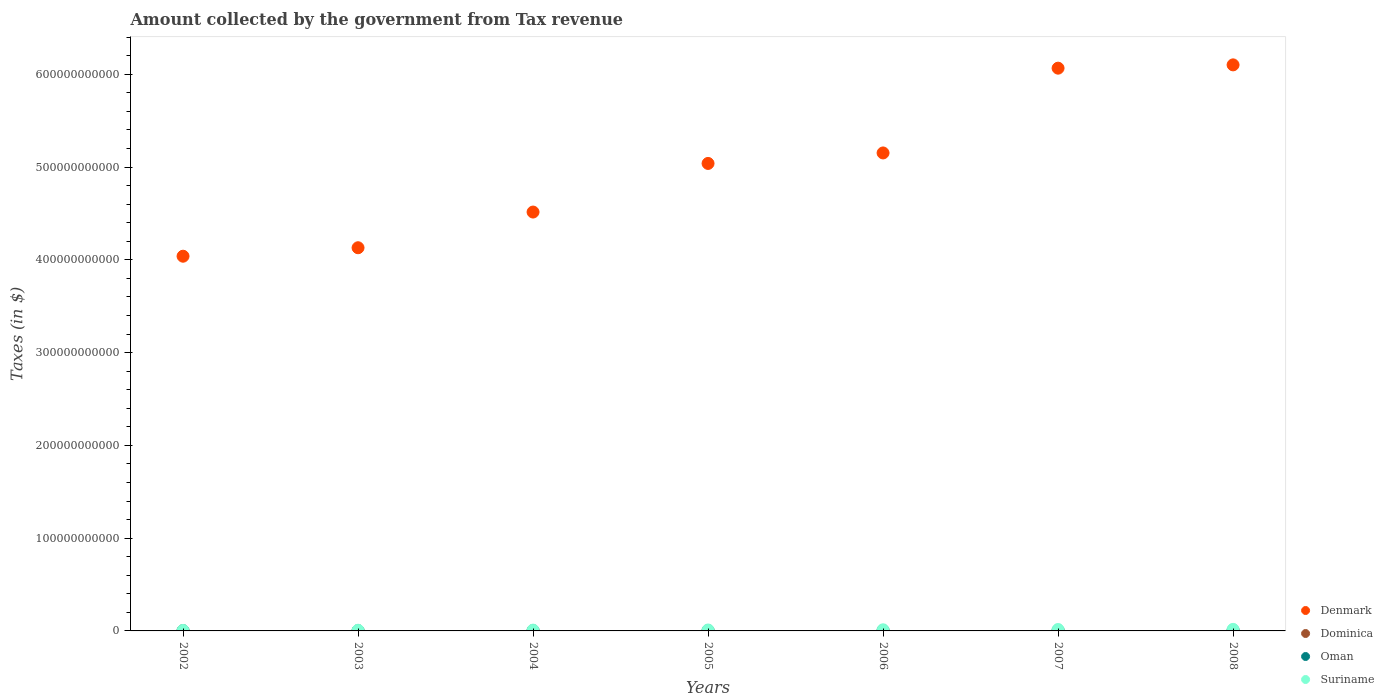How many different coloured dotlines are there?
Offer a terse response. 4. Is the number of dotlines equal to the number of legend labels?
Your answer should be very brief. Yes. What is the amount collected by the government from tax revenue in Oman in 2004?
Keep it short and to the point. 1.85e+08. Across all years, what is the maximum amount collected by the government from tax revenue in Oman?
Your answer should be compact. 5.66e+08. Across all years, what is the minimum amount collected by the government from tax revenue in Suriname?
Make the answer very short. 5.24e+08. What is the total amount collected by the government from tax revenue in Denmark in the graph?
Give a very brief answer. 3.50e+12. What is the difference between the amount collected by the government from tax revenue in Oman in 2004 and that in 2007?
Your response must be concise. -2.52e+08. What is the difference between the amount collected by the government from tax revenue in Suriname in 2004 and the amount collected by the government from tax revenue in Dominica in 2005?
Your response must be concise. 6.24e+08. What is the average amount collected by the government from tax revenue in Denmark per year?
Provide a short and direct response. 5.01e+11. In the year 2007, what is the difference between the amount collected by the government from tax revenue in Oman and amount collected by the government from tax revenue in Suriname?
Provide a short and direct response. -1.08e+09. What is the ratio of the amount collected by the government from tax revenue in Dominica in 2002 to that in 2005?
Keep it short and to the point. 0.71. Is the amount collected by the government from tax revenue in Oman in 2002 less than that in 2008?
Your answer should be compact. Yes. Is the difference between the amount collected by the government from tax revenue in Oman in 2006 and 2007 greater than the difference between the amount collected by the government from tax revenue in Suriname in 2006 and 2007?
Your answer should be very brief. Yes. What is the difference between the highest and the second highest amount collected by the government from tax revenue in Oman?
Provide a succinct answer. 1.28e+08. What is the difference between the highest and the lowest amount collected by the government from tax revenue in Denmark?
Offer a terse response. 2.06e+11. Is it the case that in every year, the sum of the amount collected by the government from tax revenue in Suriname and amount collected by the government from tax revenue in Denmark  is greater than the sum of amount collected by the government from tax revenue in Oman and amount collected by the government from tax revenue in Dominica?
Provide a short and direct response. Yes. Is the amount collected by the government from tax revenue in Suriname strictly greater than the amount collected by the government from tax revenue in Oman over the years?
Provide a short and direct response. Yes. Is the amount collected by the government from tax revenue in Oman strictly less than the amount collected by the government from tax revenue in Dominica over the years?
Provide a succinct answer. No. What is the difference between two consecutive major ticks on the Y-axis?
Provide a succinct answer. 1.00e+11. Are the values on the major ticks of Y-axis written in scientific E-notation?
Your response must be concise. No. Where does the legend appear in the graph?
Offer a very short reply. Bottom right. What is the title of the graph?
Offer a terse response. Amount collected by the government from Tax revenue. What is the label or title of the Y-axis?
Offer a very short reply. Taxes (in $). What is the Taxes (in $) of Denmark in 2002?
Give a very brief answer. 4.04e+11. What is the Taxes (in $) of Dominica in 2002?
Offer a terse response. 1.62e+08. What is the Taxes (in $) of Oman in 2002?
Your answer should be very brief. 1.55e+08. What is the Taxes (in $) of Suriname in 2002?
Keep it short and to the point. 5.24e+08. What is the Taxes (in $) in Denmark in 2003?
Your answer should be very brief. 4.13e+11. What is the Taxes (in $) of Dominica in 2003?
Keep it short and to the point. 1.79e+08. What is the Taxes (in $) of Oman in 2003?
Make the answer very short. 1.70e+08. What is the Taxes (in $) in Suriname in 2003?
Ensure brevity in your answer.  7.12e+08. What is the Taxes (in $) of Denmark in 2004?
Keep it short and to the point. 4.52e+11. What is the Taxes (in $) in Dominica in 2004?
Your answer should be very brief. 2.05e+08. What is the Taxes (in $) of Oman in 2004?
Keep it short and to the point. 1.85e+08. What is the Taxes (in $) of Suriname in 2004?
Ensure brevity in your answer.  8.53e+08. What is the Taxes (in $) of Denmark in 2005?
Give a very brief answer. 5.04e+11. What is the Taxes (in $) in Dominica in 2005?
Give a very brief answer. 2.29e+08. What is the Taxes (in $) of Oman in 2005?
Offer a very short reply. 2.39e+08. What is the Taxes (in $) of Suriname in 2005?
Make the answer very short. 1.01e+09. What is the Taxes (in $) in Denmark in 2006?
Your answer should be very brief. 5.15e+11. What is the Taxes (in $) in Dominica in 2006?
Your answer should be compact. 2.48e+08. What is the Taxes (in $) in Oman in 2006?
Offer a very short reply. 2.78e+08. What is the Taxes (in $) of Suriname in 2006?
Your response must be concise. 1.21e+09. What is the Taxes (in $) of Denmark in 2007?
Give a very brief answer. 6.07e+11. What is the Taxes (in $) of Dominica in 2007?
Ensure brevity in your answer.  2.86e+08. What is the Taxes (in $) in Oman in 2007?
Your answer should be compact. 4.38e+08. What is the Taxes (in $) in Suriname in 2007?
Provide a short and direct response. 1.52e+09. What is the Taxes (in $) in Denmark in 2008?
Ensure brevity in your answer.  6.10e+11. What is the Taxes (in $) in Dominica in 2008?
Offer a terse response. 3.07e+08. What is the Taxes (in $) of Oman in 2008?
Keep it short and to the point. 5.66e+08. What is the Taxes (in $) in Suriname in 2008?
Provide a short and direct response. 1.68e+09. Across all years, what is the maximum Taxes (in $) in Denmark?
Give a very brief answer. 6.10e+11. Across all years, what is the maximum Taxes (in $) of Dominica?
Your response must be concise. 3.07e+08. Across all years, what is the maximum Taxes (in $) in Oman?
Offer a terse response. 5.66e+08. Across all years, what is the maximum Taxes (in $) of Suriname?
Your answer should be compact. 1.68e+09. Across all years, what is the minimum Taxes (in $) of Denmark?
Provide a succinct answer. 4.04e+11. Across all years, what is the minimum Taxes (in $) of Dominica?
Offer a terse response. 1.62e+08. Across all years, what is the minimum Taxes (in $) in Oman?
Offer a very short reply. 1.55e+08. Across all years, what is the minimum Taxes (in $) in Suriname?
Provide a succinct answer. 5.24e+08. What is the total Taxes (in $) in Denmark in the graph?
Offer a very short reply. 3.50e+12. What is the total Taxes (in $) of Dominica in the graph?
Ensure brevity in your answer.  1.62e+09. What is the total Taxes (in $) of Oman in the graph?
Ensure brevity in your answer.  2.03e+09. What is the total Taxes (in $) of Suriname in the graph?
Give a very brief answer. 7.51e+09. What is the difference between the Taxes (in $) of Denmark in 2002 and that in 2003?
Ensure brevity in your answer.  -9.13e+09. What is the difference between the Taxes (in $) in Dominica in 2002 and that in 2003?
Provide a short and direct response. -1.74e+07. What is the difference between the Taxes (in $) in Oman in 2002 and that in 2003?
Make the answer very short. -1.49e+07. What is the difference between the Taxes (in $) in Suriname in 2002 and that in 2003?
Your response must be concise. -1.88e+08. What is the difference between the Taxes (in $) of Denmark in 2002 and that in 2004?
Provide a succinct answer. -4.76e+1. What is the difference between the Taxes (in $) of Dominica in 2002 and that in 2004?
Provide a short and direct response. -4.32e+07. What is the difference between the Taxes (in $) in Oman in 2002 and that in 2004?
Offer a very short reply. -3.07e+07. What is the difference between the Taxes (in $) in Suriname in 2002 and that in 2004?
Ensure brevity in your answer.  -3.29e+08. What is the difference between the Taxes (in $) in Denmark in 2002 and that in 2005?
Provide a succinct answer. -1.00e+11. What is the difference between the Taxes (in $) of Dominica in 2002 and that in 2005?
Offer a very short reply. -6.73e+07. What is the difference between the Taxes (in $) of Oman in 2002 and that in 2005?
Provide a short and direct response. -8.40e+07. What is the difference between the Taxes (in $) in Suriname in 2002 and that in 2005?
Offer a very short reply. -4.83e+08. What is the difference between the Taxes (in $) in Denmark in 2002 and that in 2006?
Offer a very short reply. -1.11e+11. What is the difference between the Taxes (in $) in Dominica in 2002 and that in 2006?
Give a very brief answer. -8.59e+07. What is the difference between the Taxes (in $) in Oman in 2002 and that in 2006?
Offer a very short reply. -1.24e+08. What is the difference between the Taxes (in $) of Suriname in 2002 and that in 2006?
Your answer should be very brief. -6.83e+08. What is the difference between the Taxes (in $) in Denmark in 2002 and that in 2007?
Keep it short and to the point. -2.03e+11. What is the difference between the Taxes (in $) in Dominica in 2002 and that in 2007?
Your answer should be compact. -1.24e+08. What is the difference between the Taxes (in $) of Oman in 2002 and that in 2007?
Make the answer very short. -2.83e+08. What is the difference between the Taxes (in $) of Suriname in 2002 and that in 2007?
Offer a very short reply. -9.97e+08. What is the difference between the Taxes (in $) in Denmark in 2002 and that in 2008?
Your answer should be very brief. -2.06e+11. What is the difference between the Taxes (in $) of Dominica in 2002 and that in 2008?
Ensure brevity in your answer.  -1.45e+08. What is the difference between the Taxes (in $) in Oman in 2002 and that in 2008?
Provide a succinct answer. -4.11e+08. What is the difference between the Taxes (in $) in Suriname in 2002 and that in 2008?
Your response must be concise. -1.16e+09. What is the difference between the Taxes (in $) of Denmark in 2003 and that in 2004?
Your answer should be compact. -3.85e+1. What is the difference between the Taxes (in $) of Dominica in 2003 and that in 2004?
Make the answer very short. -2.58e+07. What is the difference between the Taxes (in $) of Oman in 2003 and that in 2004?
Make the answer very short. -1.58e+07. What is the difference between the Taxes (in $) in Suriname in 2003 and that in 2004?
Provide a succinct answer. -1.41e+08. What is the difference between the Taxes (in $) of Denmark in 2003 and that in 2005?
Your answer should be very brief. -9.09e+1. What is the difference between the Taxes (in $) in Dominica in 2003 and that in 2005?
Provide a short and direct response. -4.99e+07. What is the difference between the Taxes (in $) of Oman in 2003 and that in 2005?
Your response must be concise. -6.91e+07. What is the difference between the Taxes (in $) in Suriname in 2003 and that in 2005?
Keep it short and to the point. -2.95e+08. What is the difference between the Taxes (in $) of Denmark in 2003 and that in 2006?
Provide a succinct answer. -1.02e+11. What is the difference between the Taxes (in $) in Dominica in 2003 and that in 2006?
Offer a terse response. -6.85e+07. What is the difference between the Taxes (in $) of Oman in 2003 and that in 2006?
Keep it short and to the point. -1.09e+08. What is the difference between the Taxes (in $) of Suriname in 2003 and that in 2006?
Provide a short and direct response. -4.95e+08. What is the difference between the Taxes (in $) of Denmark in 2003 and that in 2007?
Give a very brief answer. -1.94e+11. What is the difference between the Taxes (in $) of Dominica in 2003 and that in 2007?
Give a very brief answer. -1.06e+08. What is the difference between the Taxes (in $) in Oman in 2003 and that in 2007?
Ensure brevity in your answer.  -2.68e+08. What is the difference between the Taxes (in $) of Suriname in 2003 and that in 2007?
Your response must be concise. -8.09e+08. What is the difference between the Taxes (in $) in Denmark in 2003 and that in 2008?
Provide a succinct answer. -1.97e+11. What is the difference between the Taxes (in $) in Dominica in 2003 and that in 2008?
Offer a very short reply. -1.28e+08. What is the difference between the Taxes (in $) of Oman in 2003 and that in 2008?
Your answer should be very brief. -3.96e+08. What is the difference between the Taxes (in $) of Suriname in 2003 and that in 2008?
Your answer should be compact. -9.70e+08. What is the difference between the Taxes (in $) in Denmark in 2004 and that in 2005?
Ensure brevity in your answer.  -5.24e+1. What is the difference between the Taxes (in $) of Dominica in 2004 and that in 2005?
Ensure brevity in your answer.  -2.41e+07. What is the difference between the Taxes (in $) of Oman in 2004 and that in 2005?
Offer a very short reply. -5.33e+07. What is the difference between the Taxes (in $) in Suriname in 2004 and that in 2005?
Make the answer very short. -1.54e+08. What is the difference between the Taxes (in $) of Denmark in 2004 and that in 2006?
Make the answer very short. -6.37e+1. What is the difference between the Taxes (in $) in Dominica in 2004 and that in 2006?
Ensure brevity in your answer.  -4.27e+07. What is the difference between the Taxes (in $) of Oman in 2004 and that in 2006?
Give a very brief answer. -9.28e+07. What is the difference between the Taxes (in $) of Suriname in 2004 and that in 2006?
Your answer should be compact. -3.54e+08. What is the difference between the Taxes (in $) of Denmark in 2004 and that in 2007?
Offer a terse response. -1.55e+11. What is the difference between the Taxes (in $) in Dominica in 2004 and that in 2007?
Keep it short and to the point. -8.03e+07. What is the difference between the Taxes (in $) in Oman in 2004 and that in 2007?
Your answer should be very brief. -2.52e+08. What is the difference between the Taxes (in $) of Suriname in 2004 and that in 2007?
Offer a terse response. -6.68e+08. What is the difference between the Taxes (in $) of Denmark in 2004 and that in 2008?
Your response must be concise. -1.59e+11. What is the difference between the Taxes (in $) in Dominica in 2004 and that in 2008?
Give a very brief answer. -1.02e+08. What is the difference between the Taxes (in $) in Oman in 2004 and that in 2008?
Provide a succinct answer. -3.80e+08. What is the difference between the Taxes (in $) of Suriname in 2004 and that in 2008?
Keep it short and to the point. -8.29e+08. What is the difference between the Taxes (in $) in Denmark in 2005 and that in 2006?
Your answer should be compact. -1.13e+1. What is the difference between the Taxes (in $) of Dominica in 2005 and that in 2006?
Keep it short and to the point. -1.86e+07. What is the difference between the Taxes (in $) of Oman in 2005 and that in 2006?
Your response must be concise. -3.95e+07. What is the difference between the Taxes (in $) in Suriname in 2005 and that in 2006?
Make the answer very short. -2.00e+08. What is the difference between the Taxes (in $) of Denmark in 2005 and that in 2007?
Your response must be concise. -1.03e+11. What is the difference between the Taxes (in $) of Dominica in 2005 and that in 2007?
Your answer should be very brief. -5.62e+07. What is the difference between the Taxes (in $) in Oman in 2005 and that in 2007?
Keep it short and to the point. -1.99e+08. What is the difference between the Taxes (in $) in Suriname in 2005 and that in 2007?
Offer a very short reply. -5.14e+08. What is the difference between the Taxes (in $) in Denmark in 2005 and that in 2008?
Offer a terse response. -1.06e+11. What is the difference between the Taxes (in $) in Dominica in 2005 and that in 2008?
Provide a short and direct response. -7.81e+07. What is the difference between the Taxes (in $) in Oman in 2005 and that in 2008?
Give a very brief answer. -3.27e+08. What is the difference between the Taxes (in $) of Suriname in 2005 and that in 2008?
Offer a terse response. -6.76e+08. What is the difference between the Taxes (in $) of Denmark in 2006 and that in 2007?
Your response must be concise. -9.14e+1. What is the difference between the Taxes (in $) of Dominica in 2006 and that in 2007?
Provide a succinct answer. -3.76e+07. What is the difference between the Taxes (in $) of Oman in 2006 and that in 2007?
Provide a short and direct response. -1.59e+08. What is the difference between the Taxes (in $) in Suriname in 2006 and that in 2007?
Your answer should be compact. -3.14e+08. What is the difference between the Taxes (in $) in Denmark in 2006 and that in 2008?
Keep it short and to the point. -9.49e+1. What is the difference between the Taxes (in $) in Dominica in 2006 and that in 2008?
Provide a succinct answer. -5.95e+07. What is the difference between the Taxes (in $) of Oman in 2006 and that in 2008?
Offer a terse response. -2.88e+08. What is the difference between the Taxes (in $) in Suriname in 2006 and that in 2008?
Provide a succinct answer. -4.76e+08. What is the difference between the Taxes (in $) in Denmark in 2007 and that in 2008?
Give a very brief answer. -3.56e+09. What is the difference between the Taxes (in $) in Dominica in 2007 and that in 2008?
Ensure brevity in your answer.  -2.19e+07. What is the difference between the Taxes (in $) in Oman in 2007 and that in 2008?
Your answer should be compact. -1.28e+08. What is the difference between the Taxes (in $) in Suriname in 2007 and that in 2008?
Offer a very short reply. -1.62e+08. What is the difference between the Taxes (in $) of Denmark in 2002 and the Taxes (in $) of Dominica in 2003?
Offer a very short reply. 4.04e+11. What is the difference between the Taxes (in $) of Denmark in 2002 and the Taxes (in $) of Oman in 2003?
Give a very brief answer. 4.04e+11. What is the difference between the Taxes (in $) in Denmark in 2002 and the Taxes (in $) in Suriname in 2003?
Ensure brevity in your answer.  4.03e+11. What is the difference between the Taxes (in $) of Dominica in 2002 and the Taxes (in $) of Oman in 2003?
Offer a very short reply. -7.60e+06. What is the difference between the Taxes (in $) in Dominica in 2002 and the Taxes (in $) in Suriname in 2003?
Your answer should be very brief. -5.50e+08. What is the difference between the Taxes (in $) of Oman in 2002 and the Taxes (in $) of Suriname in 2003?
Your answer should be very brief. -5.57e+08. What is the difference between the Taxes (in $) in Denmark in 2002 and the Taxes (in $) in Dominica in 2004?
Give a very brief answer. 4.04e+11. What is the difference between the Taxes (in $) in Denmark in 2002 and the Taxes (in $) in Oman in 2004?
Your answer should be compact. 4.04e+11. What is the difference between the Taxes (in $) in Denmark in 2002 and the Taxes (in $) in Suriname in 2004?
Provide a succinct answer. 4.03e+11. What is the difference between the Taxes (in $) in Dominica in 2002 and the Taxes (in $) in Oman in 2004?
Make the answer very short. -2.34e+07. What is the difference between the Taxes (in $) in Dominica in 2002 and the Taxes (in $) in Suriname in 2004?
Offer a terse response. -6.91e+08. What is the difference between the Taxes (in $) in Oman in 2002 and the Taxes (in $) in Suriname in 2004?
Ensure brevity in your answer.  -6.98e+08. What is the difference between the Taxes (in $) of Denmark in 2002 and the Taxes (in $) of Dominica in 2005?
Provide a succinct answer. 4.04e+11. What is the difference between the Taxes (in $) in Denmark in 2002 and the Taxes (in $) in Oman in 2005?
Keep it short and to the point. 4.04e+11. What is the difference between the Taxes (in $) in Denmark in 2002 and the Taxes (in $) in Suriname in 2005?
Offer a very short reply. 4.03e+11. What is the difference between the Taxes (in $) in Dominica in 2002 and the Taxes (in $) in Oman in 2005?
Your answer should be compact. -7.67e+07. What is the difference between the Taxes (in $) in Dominica in 2002 and the Taxes (in $) in Suriname in 2005?
Provide a short and direct response. -8.45e+08. What is the difference between the Taxes (in $) of Oman in 2002 and the Taxes (in $) of Suriname in 2005?
Provide a short and direct response. -8.52e+08. What is the difference between the Taxes (in $) of Denmark in 2002 and the Taxes (in $) of Dominica in 2006?
Your answer should be very brief. 4.04e+11. What is the difference between the Taxes (in $) of Denmark in 2002 and the Taxes (in $) of Oman in 2006?
Make the answer very short. 4.04e+11. What is the difference between the Taxes (in $) in Denmark in 2002 and the Taxes (in $) in Suriname in 2006?
Keep it short and to the point. 4.03e+11. What is the difference between the Taxes (in $) in Dominica in 2002 and the Taxes (in $) in Oman in 2006?
Provide a short and direct response. -1.16e+08. What is the difference between the Taxes (in $) in Dominica in 2002 and the Taxes (in $) in Suriname in 2006?
Keep it short and to the point. -1.04e+09. What is the difference between the Taxes (in $) of Oman in 2002 and the Taxes (in $) of Suriname in 2006?
Your answer should be compact. -1.05e+09. What is the difference between the Taxes (in $) of Denmark in 2002 and the Taxes (in $) of Dominica in 2007?
Provide a short and direct response. 4.04e+11. What is the difference between the Taxes (in $) of Denmark in 2002 and the Taxes (in $) of Oman in 2007?
Offer a terse response. 4.03e+11. What is the difference between the Taxes (in $) of Denmark in 2002 and the Taxes (in $) of Suriname in 2007?
Your response must be concise. 4.02e+11. What is the difference between the Taxes (in $) in Dominica in 2002 and the Taxes (in $) in Oman in 2007?
Offer a very short reply. -2.76e+08. What is the difference between the Taxes (in $) of Dominica in 2002 and the Taxes (in $) of Suriname in 2007?
Your answer should be very brief. -1.36e+09. What is the difference between the Taxes (in $) of Oman in 2002 and the Taxes (in $) of Suriname in 2007?
Your response must be concise. -1.37e+09. What is the difference between the Taxes (in $) of Denmark in 2002 and the Taxes (in $) of Dominica in 2008?
Your response must be concise. 4.04e+11. What is the difference between the Taxes (in $) of Denmark in 2002 and the Taxes (in $) of Oman in 2008?
Make the answer very short. 4.03e+11. What is the difference between the Taxes (in $) of Denmark in 2002 and the Taxes (in $) of Suriname in 2008?
Provide a short and direct response. 4.02e+11. What is the difference between the Taxes (in $) of Dominica in 2002 and the Taxes (in $) of Oman in 2008?
Offer a terse response. -4.04e+08. What is the difference between the Taxes (in $) in Dominica in 2002 and the Taxes (in $) in Suriname in 2008?
Offer a terse response. -1.52e+09. What is the difference between the Taxes (in $) of Oman in 2002 and the Taxes (in $) of Suriname in 2008?
Offer a terse response. -1.53e+09. What is the difference between the Taxes (in $) in Denmark in 2003 and the Taxes (in $) in Dominica in 2004?
Give a very brief answer. 4.13e+11. What is the difference between the Taxes (in $) of Denmark in 2003 and the Taxes (in $) of Oman in 2004?
Ensure brevity in your answer.  4.13e+11. What is the difference between the Taxes (in $) of Denmark in 2003 and the Taxes (in $) of Suriname in 2004?
Give a very brief answer. 4.12e+11. What is the difference between the Taxes (in $) in Dominica in 2003 and the Taxes (in $) in Oman in 2004?
Your answer should be very brief. -6.00e+06. What is the difference between the Taxes (in $) in Dominica in 2003 and the Taxes (in $) in Suriname in 2004?
Ensure brevity in your answer.  -6.74e+08. What is the difference between the Taxes (in $) in Oman in 2003 and the Taxes (in $) in Suriname in 2004?
Give a very brief answer. -6.84e+08. What is the difference between the Taxes (in $) in Denmark in 2003 and the Taxes (in $) in Dominica in 2005?
Your response must be concise. 4.13e+11. What is the difference between the Taxes (in $) of Denmark in 2003 and the Taxes (in $) of Oman in 2005?
Make the answer very short. 4.13e+11. What is the difference between the Taxes (in $) in Denmark in 2003 and the Taxes (in $) in Suriname in 2005?
Give a very brief answer. 4.12e+11. What is the difference between the Taxes (in $) in Dominica in 2003 and the Taxes (in $) in Oman in 2005?
Provide a short and direct response. -5.93e+07. What is the difference between the Taxes (in $) in Dominica in 2003 and the Taxes (in $) in Suriname in 2005?
Make the answer very short. -8.27e+08. What is the difference between the Taxes (in $) of Oman in 2003 and the Taxes (in $) of Suriname in 2005?
Ensure brevity in your answer.  -8.37e+08. What is the difference between the Taxes (in $) in Denmark in 2003 and the Taxes (in $) in Dominica in 2006?
Offer a very short reply. 4.13e+11. What is the difference between the Taxes (in $) of Denmark in 2003 and the Taxes (in $) of Oman in 2006?
Offer a very short reply. 4.13e+11. What is the difference between the Taxes (in $) of Denmark in 2003 and the Taxes (in $) of Suriname in 2006?
Ensure brevity in your answer.  4.12e+11. What is the difference between the Taxes (in $) of Dominica in 2003 and the Taxes (in $) of Oman in 2006?
Keep it short and to the point. -9.88e+07. What is the difference between the Taxes (in $) in Dominica in 2003 and the Taxes (in $) in Suriname in 2006?
Ensure brevity in your answer.  -1.03e+09. What is the difference between the Taxes (in $) of Oman in 2003 and the Taxes (in $) of Suriname in 2006?
Offer a terse response. -1.04e+09. What is the difference between the Taxes (in $) of Denmark in 2003 and the Taxes (in $) of Dominica in 2007?
Make the answer very short. 4.13e+11. What is the difference between the Taxes (in $) of Denmark in 2003 and the Taxes (in $) of Oman in 2007?
Your response must be concise. 4.13e+11. What is the difference between the Taxes (in $) of Denmark in 2003 and the Taxes (in $) of Suriname in 2007?
Your answer should be very brief. 4.12e+11. What is the difference between the Taxes (in $) of Dominica in 2003 and the Taxes (in $) of Oman in 2007?
Offer a very short reply. -2.58e+08. What is the difference between the Taxes (in $) of Dominica in 2003 and the Taxes (in $) of Suriname in 2007?
Offer a terse response. -1.34e+09. What is the difference between the Taxes (in $) in Oman in 2003 and the Taxes (in $) in Suriname in 2007?
Provide a succinct answer. -1.35e+09. What is the difference between the Taxes (in $) of Denmark in 2003 and the Taxes (in $) of Dominica in 2008?
Your response must be concise. 4.13e+11. What is the difference between the Taxes (in $) of Denmark in 2003 and the Taxes (in $) of Oman in 2008?
Your answer should be compact. 4.12e+11. What is the difference between the Taxes (in $) in Denmark in 2003 and the Taxes (in $) in Suriname in 2008?
Offer a terse response. 4.11e+11. What is the difference between the Taxes (in $) in Dominica in 2003 and the Taxes (in $) in Oman in 2008?
Provide a short and direct response. -3.86e+08. What is the difference between the Taxes (in $) of Dominica in 2003 and the Taxes (in $) of Suriname in 2008?
Give a very brief answer. -1.50e+09. What is the difference between the Taxes (in $) of Oman in 2003 and the Taxes (in $) of Suriname in 2008?
Your response must be concise. -1.51e+09. What is the difference between the Taxes (in $) of Denmark in 2004 and the Taxes (in $) of Dominica in 2005?
Make the answer very short. 4.51e+11. What is the difference between the Taxes (in $) of Denmark in 2004 and the Taxes (in $) of Oman in 2005?
Your answer should be very brief. 4.51e+11. What is the difference between the Taxes (in $) of Denmark in 2004 and the Taxes (in $) of Suriname in 2005?
Make the answer very short. 4.50e+11. What is the difference between the Taxes (in $) in Dominica in 2004 and the Taxes (in $) in Oman in 2005?
Make the answer very short. -3.35e+07. What is the difference between the Taxes (in $) of Dominica in 2004 and the Taxes (in $) of Suriname in 2005?
Keep it short and to the point. -8.02e+08. What is the difference between the Taxes (in $) in Oman in 2004 and the Taxes (in $) in Suriname in 2005?
Keep it short and to the point. -8.21e+08. What is the difference between the Taxes (in $) of Denmark in 2004 and the Taxes (in $) of Dominica in 2006?
Keep it short and to the point. 4.51e+11. What is the difference between the Taxes (in $) of Denmark in 2004 and the Taxes (in $) of Oman in 2006?
Provide a succinct answer. 4.51e+11. What is the difference between the Taxes (in $) in Denmark in 2004 and the Taxes (in $) in Suriname in 2006?
Your response must be concise. 4.50e+11. What is the difference between the Taxes (in $) in Dominica in 2004 and the Taxes (in $) in Oman in 2006?
Your response must be concise. -7.30e+07. What is the difference between the Taxes (in $) in Dominica in 2004 and the Taxes (in $) in Suriname in 2006?
Make the answer very short. -1.00e+09. What is the difference between the Taxes (in $) of Oman in 2004 and the Taxes (in $) of Suriname in 2006?
Give a very brief answer. -1.02e+09. What is the difference between the Taxes (in $) in Denmark in 2004 and the Taxes (in $) in Dominica in 2007?
Offer a terse response. 4.51e+11. What is the difference between the Taxes (in $) in Denmark in 2004 and the Taxes (in $) in Oman in 2007?
Your answer should be compact. 4.51e+11. What is the difference between the Taxes (in $) of Denmark in 2004 and the Taxes (in $) of Suriname in 2007?
Provide a short and direct response. 4.50e+11. What is the difference between the Taxes (in $) of Dominica in 2004 and the Taxes (in $) of Oman in 2007?
Ensure brevity in your answer.  -2.32e+08. What is the difference between the Taxes (in $) in Dominica in 2004 and the Taxes (in $) in Suriname in 2007?
Ensure brevity in your answer.  -1.32e+09. What is the difference between the Taxes (in $) of Oman in 2004 and the Taxes (in $) of Suriname in 2007?
Your response must be concise. -1.34e+09. What is the difference between the Taxes (in $) in Denmark in 2004 and the Taxes (in $) in Dominica in 2008?
Offer a terse response. 4.51e+11. What is the difference between the Taxes (in $) in Denmark in 2004 and the Taxes (in $) in Oman in 2008?
Your answer should be very brief. 4.51e+11. What is the difference between the Taxes (in $) of Denmark in 2004 and the Taxes (in $) of Suriname in 2008?
Offer a terse response. 4.50e+11. What is the difference between the Taxes (in $) of Dominica in 2004 and the Taxes (in $) of Oman in 2008?
Provide a succinct answer. -3.60e+08. What is the difference between the Taxes (in $) of Dominica in 2004 and the Taxes (in $) of Suriname in 2008?
Provide a short and direct response. -1.48e+09. What is the difference between the Taxes (in $) in Oman in 2004 and the Taxes (in $) in Suriname in 2008?
Provide a short and direct response. -1.50e+09. What is the difference between the Taxes (in $) of Denmark in 2005 and the Taxes (in $) of Dominica in 2006?
Provide a short and direct response. 5.04e+11. What is the difference between the Taxes (in $) of Denmark in 2005 and the Taxes (in $) of Oman in 2006?
Offer a terse response. 5.04e+11. What is the difference between the Taxes (in $) of Denmark in 2005 and the Taxes (in $) of Suriname in 2006?
Your answer should be compact. 5.03e+11. What is the difference between the Taxes (in $) in Dominica in 2005 and the Taxes (in $) in Oman in 2006?
Ensure brevity in your answer.  -4.89e+07. What is the difference between the Taxes (in $) of Dominica in 2005 and the Taxes (in $) of Suriname in 2006?
Offer a terse response. -9.78e+08. What is the difference between the Taxes (in $) in Oman in 2005 and the Taxes (in $) in Suriname in 2006?
Offer a terse response. -9.68e+08. What is the difference between the Taxes (in $) of Denmark in 2005 and the Taxes (in $) of Dominica in 2007?
Provide a short and direct response. 5.04e+11. What is the difference between the Taxes (in $) in Denmark in 2005 and the Taxes (in $) in Oman in 2007?
Ensure brevity in your answer.  5.03e+11. What is the difference between the Taxes (in $) in Denmark in 2005 and the Taxes (in $) in Suriname in 2007?
Make the answer very short. 5.02e+11. What is the difference between the Taxes (in $) in Dominica in 2005 and the Taxes (in $) in Oman in 2007?
Your response must be concise. -2.08e+08. What is the difference between the Taxes (in $) in Dominica in 2005 and the Taxes (in $) in Suriname in 2007?
Provide a succinct answer. -1.29e+09. What is the difference between the Taxes (in $) in Oman in 2005 and the Taxes (in $) in Suriname in 2007?
Make the answer very short. -1.28e+09. What is the difference between the Taxes (in $) of Denmark in 2005 and the Taxes (in $) of Dominica in 2008?
Keep it short and to the point. 5.04e+11. What is the difference between the Taxes (in $) of Denmark in 2005 and the Taxes (in $) of Oman in 2008?
Make the answer very short. 5.03e+11. What is the difference between the Taxes (in $) of Denmark in 2005 and the Taxes (in $) of Suriname in 2008?
Make the answer very short. 5.02e+11. What is the difference between the Taxes (in $) in Dominica in 2005 and the Taxes (in $) in Oman in 2008?
Offer a terse response. -3.36e+08. What is the difference between the Taxes (in $) in Dominica in 2005 and the Taxes (in $) in Suriname in 2008?
Offer a terse response. -1.45e+09. What is the difference between the Taxes (in $) of Oman in 2005 and the Taxes (in $) of Suriname in 2008?
Ensure brevity in your answer.  -1.44e+09. What is the difference between the Taxes (in $) of Denmark in 2006 and the Taxes (in $) of Dominica in 2007?
Provide a short and direct response. 5.15e+11. What is the difference between the Taxes (in $) of Denmark in 2006 and the Taxes (in $) of Oman in 2007?
Make the answer very short. 5.15e+11. What is the difference between the Taxes (in $) in Denmark in 2006 and the Taxes (in $) in Suriname in 2007?
Offer a very short reply. 5.14e+11. What is the difference between the Taxes (in $) of Dominica in 2006 and the Taxes (in $) of Oman in 2007?
Offer a very short reply. -1.90e+08. What is the difference between the Taxes (in $) of Dominica in 2006 and the Taxes (in $) of Suriname in 2007?
Provide a short and direct response. -1.27e+09. What is the difference between the Taxes (in $) of Oman in 2006 and the Taxes (in $) of Suriname in 2007?
Your answer should be compact. -1.24e+09. What is the difference between the Taxes (in $) in Denmark in 2006 and the Taxes (in $) in Dominica in 2008?
Ensure brevity in your answer.  5.15e+11. What is the difference between the Taxes (in $) of Denmark in 2006 and the Taxes (in $) of Oman in 2008?
Your answer should be compact. 5.15e+11. What is the difference between the Taxes (in $) of Denmark in 2006 and the Taxes (in $) of Suriname in 2008?
Your response must be concise. 5.14e+11. What is the difference between the Taxes (in $) of Dominica in 2006 and the Taxes (in $) of Oman in 2008?
Give a very brief answer. -3.18e+08. What is the difference between the Taxes (in $) in Dominica in 2006 and the Taxes (in $) in Suriname in 2008?
Offer a terse response. -1.43e+09. What is the difference between the Taxes (in $) of Oman in 2006 and the Taxes (in $) of Suriname in 2008?
Give a very brief answer. -1.40e+09. What is the difference between the Taxes (in $) of Denmark in 2007 and the Taxes (in $) of Dominica in 2008?
Provide a short and direct response. 6.06e+11. What is the difference between the Taxes (in $) in Denmark in 2007 and the Taxes (in $) in Oman in 2008?
Offer a terse response. 6.06e+11. What is the difference between the Taxes (in $) of Denmark in 2007 and the Taxes (in $) of Suriname in 2008?
Your answer should be very brief. 6.05e+11. What is the difference between the Taxes (in $) of Dominica in 2007 and the Taxes (in $) of Oman in 2008?
Keep it short and to the point. -2.80e+08. What is the difference between the Taxes (in $) of Dominica in 2007 and the Taxes (in $) of Suriname in 2008?
Make the answer very short. -1.40e+09. What is the difference between the Taxes (in $) of Oman in 2007 and the Taxes (in $) of Suriname in 2008?
Make the answer very short. -1.24e+09. What is the average Taxes (in $) in Denmark per year?
Keep it short and to the point. 5.01e+11. What is the average Taxes (in $) in Dominica per year?
Offer a very short reply. 2.31e+08. What is the average Taxes (in $) of Oman per year?
Your answer should be very brief. 2.90e+08. What is the average Taxes (in $) in Suriname per year?
Make the answer very short. 1.07e+09. In the year 2002, what is the difference between the Taxes (in $) in Denmark and Taxes (in $) in Dominica?
Provide a succinct answer. 4.04e+11. In the year 2002, what is the difference between the Taxes (in $) of Denmark and Taxes (in $) of Oman?
Your answer should be compact. 4.04e+11. In the year 2002, what is the difference between the Taxes (in $) of Denmark and Taxes (in $) of Suriname?
Provide a short and direct response. 4.03e+11. In the year 2002, what is the difference between the Taxes (in $) of Dominica and Taxes (in $) of Oman?
Give a very brief answer. 7.30e+06. In the year 2002, what is the difference between the Taxes (in $) of Dominica and Taxes (in $) of Suriname?
Your answer should be very brief. -3.62e+08. In the year 2002, what is the difference between the Taxes (in $) in Oman and Taxes (in $) in Suriname?
Provide a short and direct response. -3.69e+08. In the year 2003, what is the difference between the Taxes (in $) in Denmark and Taxes (in $) in Dominica?
Your response must be concise. 4.13e+11. In the year 2003, what is the difference between the Taxes (in $) of Denmark and Taxes (in $) of Oman?
Offer a terse response. 4.13e+11. In the year 2003, what is the difference between the Taxes (in $) in Denmark and Taxes (in $) in Suriname?
Your response must be concise. 4.12e+11. In the year 2003, what is the difference between the Taxes (in $) of Dominica and Taxes (in $) of Oman?
Make the answer very short. 9.80e+06. In the year 2003, what is the difference between the Taxes (in $) in Dominica and Taxes (in $) in Suriname?
Offer a terse response. -5.33e+08. In the year 2003, what is the difference between the Taxes (in $) of Oman and Taxes (in $) of Suriname?
Provide a short and direct response. -5.42e+08. In the year 2004, what is the difference between the Taxes (in $) in Denmark and Taxes (in $) in Dominica?
Your answer should be compact. 4.51e+11. In the year 2004, what is the difference between the Taxes (in $) in Denmark and Taxes (in $) in Oman?
Offer a terse response. 4.51e+11. In the year 2004, what is the difference between the Taxes (in $) of Denmark and Taxes (in $) of Suriname?
Ensure brevity in your answer.  4.51e+11. In the year 2004, what is the difference between the Taxes (in $) in Dominica and Taxes (in $) in Oman?
Offer a terse response. 1.98e+07. In the year 2004, what is the difference between the Taxes (in $) of Dominica and Taxes (in $) of Suriname?
Give a very brief answer. -6.48e+08. In the year 2004, what is the difference between the Taxes (in $) of Oman and Taxes (in $) of Suriname?
Give a very brief answer. -6.68e+08. In the year 2005, what is the difference between the Taxes (in $) in Denmark and Taxes (in $) in Dominica?
Your answer should be compact. 5.04e+11. In the year 2005, what is the difference between the Taxes (in $) in Denmark and Taxes (in $) in Oman?
Give a very brief answer. 5.04e+11. In the year 2005, what is the difference between the Taxes (in $) in Denmark and Taxes (in $) in Suriname?
Provide a short and direct response. 5.03e+11. In the year 2005, what is the difference between the Taxes (in $) in Dominica and Taxes (in $) in Oman?
Your answer should be very brief. -9.40e+06. In the year 2005, what is the difference between the Taxes (in $) in Dominica and Taxes (in $) in Suriname?
Offer a very short reply. -7.77e+08. In the year 2005, what is the difference between the Taxes (in $) of Oman and Taxes (in $) of Suriname?
Your response must be concise. -7.68e+08. In the year 2006, what is the difference between the Taxes (in $) of Denmark and Taxes (in $) of Dominica?
Make the answer very short. 5.15e+11. In the year 2006, what is the difference between the Taxes (in $) of Denmark and Taxes (in $) of Oman?
Provide a succinct answer. 5.15e+11. In the year 2006, what is the difference between the Taxes (in $) in Denmark and Taxes (in $) in Suriname?
Offer a very short reply. 5.14e+11. In the year 2006, what is the difference between the Taxes (in $) in Dominica and Taxes (in $) in Oman?
Give a very brief answer. -3.03e+07. In the year 2006, what is the difference between the Taxes (in $) of Dominica and Taxes (in $) of Suriname?
Make the answer very short. -9.59e+08. In the year 2006, what is the difference between the Taxes (in $) of Oman and Taxes (in $) of Suriname?
Provide a succinct answer. -9.29e+08. In the year 2007, what is the difference between the Taxes (in $) in Denmark and Taxes (in $) in Dominica?
Give a very brief answer. 6.06e+11. In the year 2007, what is the difference between the Taxes (in $) of Denmark and Taxes (in $) of Oman?
Your response must be concise. 6.06e+11. In the year 2007, what is the difference between the Taxes (in $) in Denmark and Taxes (in $) in Suriname?
Ensure brevity in your answer.  6.05e+11. In the year 2007, what is the difference between the Taxes (in $) of Dominica and Taxes (in $) of Oman?
Provide a short and direct response. -1.52e+08. In the year 2007, what is the difference between the Taxes (in $) in Dominica and Taxes (in $) in Suriname?
Offer a very short reply. -1.24e+09. In the year 2007, what is the difference between the Taxes (in $) of Oman and Taxes (in $) of Suriname?
Your answer should be compact. -1.08e+09. In the year 2008, what is the difference between the Taxes (in $) of Denmark and Taxes (in $) of Dominica?
Provide a short and direct response. 6.10e+11. In the year 2008, what is the difference between the Taxes (in $) of Denmark and Taxes (in $) of Oman?
Your answer should be compact. 6.10e+11. In the year 2008, what is the difference between the Taxes (in $) of Denmark and Taxes (in $) of Suriname?
Ensure brevity in your answer.  6.08e+11. In the year 2008, what is the difference between the Taxes (in $) of Dominica and Taxes (in $) of Oman?
Your answer should be very brief. -2.58e+08. In the year 2008, what is the difference between the Taxes (in $) in Dominica and Taxes (in $) in Suriname?
Ensure brevity in your answer.  -1.38e+09. In the year 2008, what is the difference between the Taxes (in $) of Oman and Taxes (in $) of Suriname?
Offer a terse response. -1.12e+09. What is the ratio of the Taxes (in $) of Denmark in 2002 to that in 2003?
Offer a very short reply. 0.98. What is the ratio of the Taxes (in $) in Dominica in 2002 to that in 2003?
Provide a short and direct response. 0.9. What is the ratio of the Taxes (in $) in Oman in 2002 to that in 2003?
Make the answer very short. 0.91. What is the ratio of the Taxes (in $) in Suriname in 2002 to that in 2003?
Offer a very short reply. 0.74. What is the ratio of the Taxes (in $) of Denmark in 2002 to that in 2004?
Provide a short and direct response. 0.89. What is the ratio of the Taxes (in $) of Dominica in 2002 to that in 2004?
Your answer should be compact. 0.79. What is the ratio of the Taxes (in $) in Oman in 2002 to that in 2004?
Offer a very short reply. 0.83. What is the ratio of the Taxes (in $) in Suriname in 2002 to that in 2004?
Give a very brief answer. 0.61. What is the ratio of the Taxes (in $) of Denmark in 2002 to that in 2005?
Your response must be concise. 0.8. What is the ratio of the Taxes (in $) of Dominica in 2002 to that in 2005?
Your answer should be very brief. 0.71. What is the ratio of the Taxes (in $) in Oman in 2002 to that in 2005?
Offer a terse response. 0.65. What is the ratio of the Taxes (in $) in Suriname in 2002 to that in 2005?
Keep it short and to the point. 0.52. What is the ratio of the Taxes (in $) in Denmark in 2002 to that in 2006?
Make the answer very short. 0.78. What is the ratio of the Taxes (in $) in Dominica in 2002 to that in 2006?
Offer a terse response. 0.65. What is the ratio of the Taxes (in $) of Oman in 2002 to that in 2006?
Offer a very short reply. 0.56. What is the ratio of the Taxes (in $) of Suriname in 2002 to that in 2006?
Offer a terse response. 0.43. What is the ratio of the Taxes (in $) of Denmark in 2002 to that in 2007?
Offer a very short reply. 0.67. What is the ratio of the Taxes (in $) of Dominica in 2002 to that in 2007?
Offer a very short reply. 0.57. What is the ratio of the Taxes (in $) of Oman in 2002 to that in 2007?
Keep it short and to the point. 0.35. What is the ratio of the Taxes (in $) in Suriname in 2002 to that in 2007?
Your answer should be compact. 0.34. What is the ratio of the Taxes (in $) in Denmark in 2002 to that in 2008?
Give a very brief answer. 0.66. What is the ratio of the Taxes (in $) of Dominica in 2002 to that in 2008?
Keep it short and to the point. 0.53. What is the ratio of the Taxes (in $) of Oman in 2002 to that in 2008?
Your response must be concise. 0.27. What is the ratio of the Taxes (in $) of Suriname in 2002 to that in 2008?
Your answer should be very brief. 0.31. What is the ratio of the Taxes (in $) in Denmark in 2003 to that in 2004?
Your answer should be very brief. 0.91. What is the ratio of the Taxes (in $) in Dominica in 2003 to that in 2004?
Offer a very short reply. 0.87. What is the ratio of the Taxes (in $) in Oman in 2003 to that in 2004?
Your answer should be very brief. 0.91. What is the ratio of the Taxes (in $) in Suriname in 2003 to that in 2004?
Offer a very short reply. 0.83. What is the ratio of the Taxes (in $) of Denmark in 2003 to that in 2005?
Your answer should be compact. 0.82. What is the ratio of the Taxes (in $) in Dominica in 2003 to that in 2005?
Your answer should be very brief. 0.78. What is the ratio of the Taxes (in $) of Oman in 2003 to that in 2005?
Keep it short and to the point. 0.71. What is the ratio of the Taxes (in $) in Suriname in 2003 to that in 2005?
Provide a short and direct response. 0.71. What is the ratio of the Taxes (in $) in Denmark in 2003 to that in 2006?
Your response must be concise. 0.8. What is the ratio of the Taxes (in $) of Dominica in 2003 to that in 2006?
Ensure brevity in your answer.  0.72. What is the ratio of the Taxes (in $) in Oman in 2003 to that in 2006?
Offer a terse response. 0.61. What is the ratio of the Taxes (in $) in Suriname in 2003 to that in 2006?
Provide a short and direct response. 0.59. What is the ratio of the Taxes (in $) of Denmark in 2003 to that in 2007?
Keep it short and to the point. 0.68. What is the ratio of the Taxes (in $) in Dominica in 2003 to that in 2007?
Provide a succinct answer. 0.63. What is the ratio of the Taxes (in $) of Oman in 2003 to that in 2007?
Provide a succinct answer. 0.39. What is the ratio of the Taxes (in $) of Suriname in 2003 to that in 2007?
Provide a succinct answer. 0.47. What is the ratio of the Taxes (in $) of Denmark in 2003 to that in 2008?
Your answer should be very brief. 0.68. What is the ratio of the Taxes (in $) of Dominica in 2003 to that in 2008?
Make the answer very short. 0.58. What is the ratio of the Taxes (in $) of Oman in 2003 to that in 2008?
Ensure brevity in your answer.  0.3. What is the ratio of the Taxes (in $) of Suriname in 2003 to that in 2008?
Your answer should be very brief. 0.42. What is the ratio of the Taxes (in $) of Denmark in 2004 to that in 2005?
Offer a very short reply. 0.9. What is the ratio of the Taxes (in $) in Dominica in 2004 to that in 2005?
Make the answer very short. 0.89. What is the ratio of the Taxes (in $) of Oman in 2004 to that in 2005?
Offer a terse response. 0.78. What is the ratio of the Taxes (in $) of Suriname in 2004 to that in 2005?
Your answer should be very brief. 0.85. What is the ratio of the Taxes (in $) of Denmark in 2004 to that in 2006?
Give a very brief answer. 0.88. What is the ratio of the Taxes (in $) in Dominica in 2004 to that in 2006?
Offer a very short reply. 0.83. What is the ratio of the Taxes (in $) of Oman in 2004 to that in 2006?
Provide a short and direct response. 0.67. What is the ratio of the Taxes (in $) of Suriname in 2004 to that in 2006?
Give a very brief answer. 0.71. What is the ratio of the Taxes (in $) in Denmark in 2004 to that in 2007?
Offer a very short reply. 0.74. What is the ratio of the Taxes (in $) in Dominica in 2004 to that in 2007?
Keep it short and to the point. 0.72. What is the ratio of the Taxes (in $) of Oman in 2004 to that in 2007?
Your answer should be compact. 0.42. What is the ratio of the Taxes (in $) in Suriname in 2004 to that in 2007?
Ensure brevity in your answer.  0.56. What is the ratio of the Taxes (in $) of Denmark in 2004 to that in 2008?
Your response must be concise. 0.74. What is the ratio of the Taxes (in $) in Dominica in 2004 to that in 2008?
Keep it short and to the point. 0.67. What is the ratio of the Taxes (in $) of Oman in 2004 to that in 2008?
Ensure brevity in your answer.  0.33. What is the ratio of the Taxes (in $) of Suriname in 2004 to that in 2008?
Offer a very short reply. 0.51. What is the ratio of the Taxes (in $) in Denmark in 2005 to that in 2006?
Keep it short and to the point. 0.98. What is the ratio of the Taxes (in $) of Dominica in 2005 to that in 2006?
Make the answer very short. 0.93. What is the ratio of the Taxes (in $) of Oman in 2005 to that in 2006?
Keep it short and to the point. 0.86. What is the ratio of the Taxes (in $) of Suriname in 2005 to that in 2006?
Your response must be concise. 0.83. What is the ratio of the Taxes (in $) in Denmark in 2005 to that in 2007?
Give a very brief answer. 0.83. What is the ratio of the Taxes (in $) in Dominica in 2005 to that in 2007?
Offer a terse response. 0.8. What is the ratio of the Taxes (in $) in Oman in 2005 to that in 2007?
Provide a succinct answer. 0.55. What is the ratio of the Taxes (in $) of Suriname in 2005 to that in 2007?
Give a very brief answer. 0.66. What is the ratio of the Taxes (in $) of Denmark in 2005 to that in 2008?
Your response must be concise. 0.83. What is the ratio of the Taxes (in $) of Dominica in 2005 to that in 2008?
Make the answer very short. 0.75. What is the ratio of the Taxes (in $) in Oman in 2005 to that in 2008?
Your answer should be very brief. 0.42. What is the ratio of the Taxes (in $) in Suriname in 2005 to that in 2008?
Ensure brevity in your answer.  0.6. What is the ratio of the Taxes (in $) of Denmark in 2006 to that in 2007?
Your answer should be compact. 0.85. What is the ratio of the Taxes (in $) in Dominica in 2006 to that in 2007?
Give a very brief answer. 0.87. What is the ratio of the Taxes (in $) in Oman in 2006 to that in 2007?
Keep it short and to the point. 0.64. What is the ratio of the Taxes (in $) in Suriname in 2006 to that in 2007?
Provide a short and direct response. 0.79. What is the ratio of the Taxes (in $) of Denmark in 2006 to that in 2008?
Provide a short and direct response. 0.84. What is the ratio of the Taxes (in $) of Dominica in 2006 to that in 2008?
Your answer should be very brief. 0.81. What is the ratio of the Taxes (in $) of Oman in 2006 to that in 2008?
Keep it short and to the point. 0.49. What is the ratio of the Taxes (in $) of Suriname in 2006 to that in 2008?
Your answer should be very brief. 0.72. What is the ratio of the Taxes (in $) of Denmark in 2007 to that in 2008?
Give a very brief answer. 0.99. What is the ratio of the Taxes (in $) in Dominica in 2007 to that in 2008?
Make the answer very short. 0.93. What is the ratio of the Taxes (in $) of Oman in 2007 to that in 2008?
Give a very brief answer. 0.77. What is the ratio of the Taxes (in $) in Suriname in 2007 to that in 2008?
Give a very brief answer. 0.9. What is the difference between the highest and the second highest Taxes (in $) in Denmark?
Ensure brevity in your answer.  3.56e+09. What is the difference between the highest and the second highest Taxes (in $) of Dominica?
Ensure brevity in your answer.  2.19e+07. What is the difference between the highest and the second highest Taxes (in $) of Oman?
Offer a terse response. 1.28e+08. What is the difference between the highest and the second highest Taxes (in $) in Suriname?
Provide a succinct answer. 1.62e+08. What is the difference between the highest and the lowest Taxes (in $) of Denmark?
Provide a succinct answer. 2.06e+11. What is the difference between the highest and the lowest Taxes (in $) in Dominica?
Your answer should be compact. 1.45e+08. What is the difference between the highest and the lowest Taxes (in $) of Oman?
Give a very brief answer. 4.11e+08. What is the difference between the highest and the lowest Taxes (in $) in Suriname?
Offer a very short reply. 1.16e+09. 